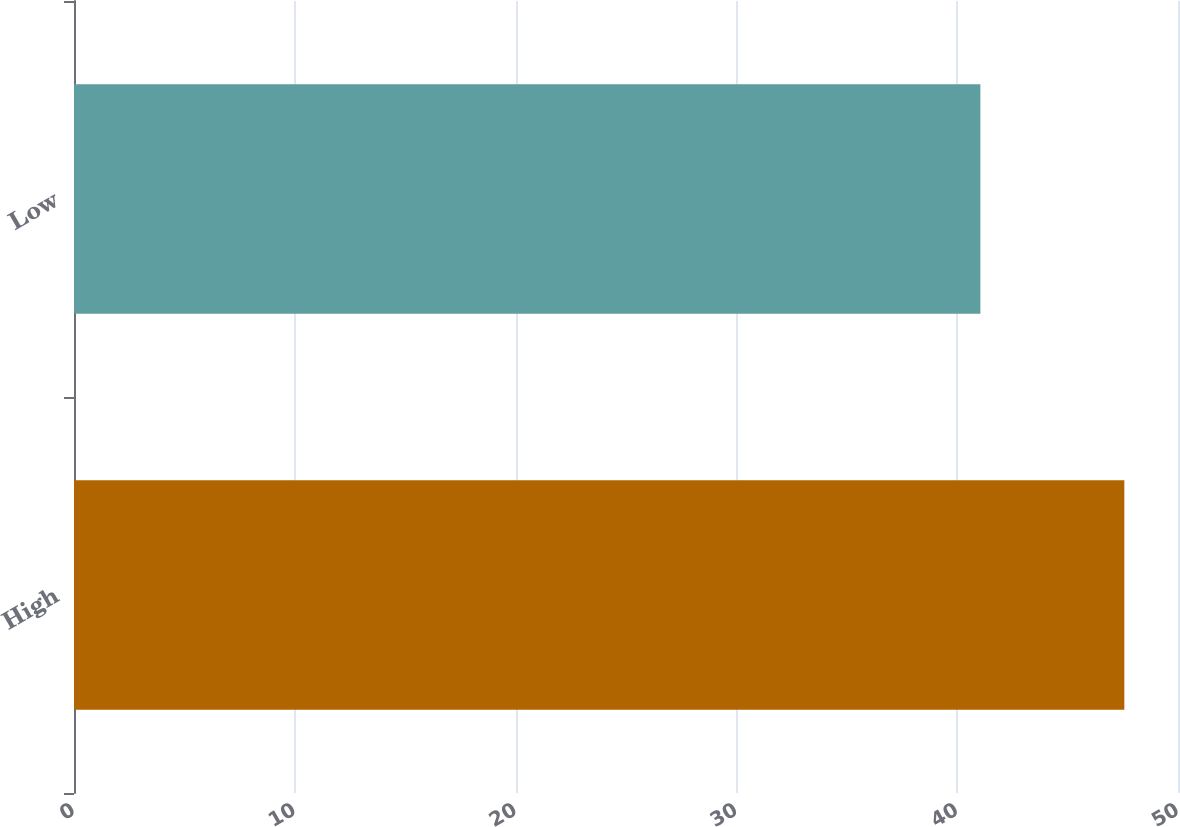Convert chart to OTSL. <chart><loc_0><loc_0><loc_500><loc_500><bar_chart><fcel>High<fcel>Low<nl><fcel>47.57<fcel>41.05<nl></chart> 